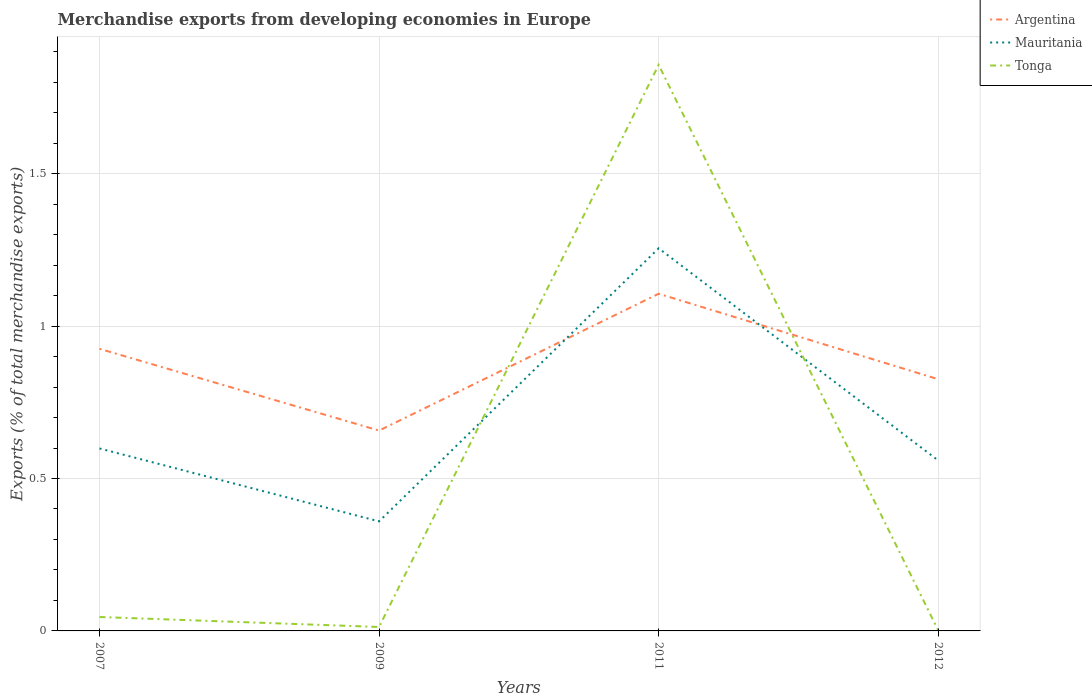How many different coloured lines are there?
Make the answer very short. 3. Across all years, what is the maximum percentage of total merchandise exports in Tonga?
Ensure brevity in your answer.  0. In which year was the percentage of total merchandise exports in Mauritania maximum?
Offer a very short reply. 2009. What is the total percentage of total merchandise exports in Argentina in the graph?
Provide a short and direct response. -0.45. What is the difference between the highest and the second highest percentage of total merchandise exports in Mauritania?
Make the answer very short. 0.9. How many lines are there?
Provide a succinct answer. 3. How many years are there in the graph?
Your response must be concise. 4. What is the difference between two consecutive major ticks on the Y-axis?
Your answer should be very brief. 0.5. Does the graph contain any zero values?
Your answer should be very brief. No. How many legend labels are there?
Keep it short and to the point. 3. How are the legend labels stacked?
Give a very brief answer. Vertical. What is the title of the graph?
Your answer should be very brief. Merchandise exports from developing economies in Europe. What is the label or title of the X-axis?
Provide a short and direct response. Years. What is the label or title of the Y-axis?
Give a very brief answer. Exports (% of total merchandise exports). What is the Exports (% of total merchandise exports) of Argentina in 2007?
Your answer should be very brief. 0.93. What is the Exports (% of total merchandise exports) of Mauritania in 2007?
Keep it short and to the point. 0.6. What is the Exports (% of total merchandise exports) of Tonga in 2007?
Your answer should be compact. 0.05. What is the Exports (% of total merchandise exports) in Argentina in 2009?
Make the answer very short. 0.66. What is the Exports (% of total merchandise exports) of Mauritania in 2009?
Keep it short and to the point. 0.36. What is the Exports (% of total merchandise exports) in Tonga in 2009?
Make the answer very short. 0.01. What is the Exports (% of total merchandise exports) of Argentina in 2011?
Offer a very short reply. 1.11. What is the Exports (% of total merchandise exports) of Mauritania in 2011?
Give a very brief answer. 1.26. What is the Exports (% of total merchandise exports) of Tonga in 2011?
Ensure brevity in your answer.  1.86. What is the Exports (% of total merchandise exports) of Argentina in 2012?
Your answer should be very brief. 0.83. What is the Exports (% of total merchandise exports) of Mauritania in 2012?
Ensure brevity in your answer.  0.56. What is the Exports (% of total merchandise exports) of Tonga in 2012?
Your response must be concise. 0. Across all years, what is the maximum Exports (% of total merchandise exports) in Argentina?
Offer a very short reply. 1.11. Across all years, what is the maximum Exports (% of total merchandise exports) of Mauritania?
Offer a terse response. 1.26. Across all years, what is the maximum Exports (% of total merchandise exports) of Tonga?
Give a very brief answer. 1.86. Across all years, what is the minimum Exports (% of total merchandise exports) in Argentina?
Give a very brief answer. 0.66. Across all years, what is the minimum Exports (% of total merchandise exports) of Mauritania?
Give a very brief answer. 0.36. Across all years, what is the minimum Exports (% of total merchandise exports) in Tonga?
Your response must be concise. 0. What is the total Exports (% of total merchandise exports) of Argentina in the graph?
Keep it short and to the point. 3.51. What is the total Exports (% of total merchandise exports) of Mauritania in the graph?
Your response must be concise. 2.77. What is the total Exports (% of total merchandise exports) in Tonga in the graph?
Give a very brief answer. 1.92. What is the difference between the Exports (% of total merchandise exports) in Argentina in 2007 and that in 2009?
Keep it short and to the point. 0.27. What is the difference between the Exports (% of total merchandise exports) of Mauritania in 2007 and that in 2009?
Ensure brevity in your answer.  0.24. What is the difference between the Exports (% of total merchandise exports) of Tonga in 2007 and that in 2009?
Provide a short and direct response. 0.03. What is the difference between the Exports (% of total merchandise exports) in Argentina in 2007 and that in 2011?
Your answer should be compact. -0.18. What is the difference between the Exports (% of total merchandise exports) of Mauritania in 2007 and that in 2011?
Your answer should be compact. -0.66. What is the difference between the Exports (% of total merchandise exports) in Tonga in 2007 and that in 2011?
Keep it short and to the point. -1.81. What is the difference between the Exports (% of total merchandise exports) in Argentina in 2007 and that in 2012?
Your answer should be compact. 0.1. What is the difference between the Exports (% of total merchandise exports) in Mauritania in 2007 and that in 2012?
Your answer should be very brief. 0.04. What is the difference between the Exports (% of total merchandise exports) of Tonga in 2007 and that in 2012?
Your response must be concise. 0.04. What is the difference between the Exports (% of total merchandise exports) in Argentina in 2009 and that in 2011?
Provide a short and direct response. -0.45. What is the difference between the Exports (% of total merchandise exports) in Mauritania in 2009 and that in 2011?
Offer a terse response. -0.9. What is the difference between the Exports (% of total merchandise exports) in Tonga in 2009 and that in 2011?
Your answer should be very brief. -1.84. What is the difference between the Exports (% of total merchandise exports) of Argentina in 2009 and that in 2012?
Make the answer very short. -0.17. What is the difference between the Exports (% of total merchandise exports) in Mauritania in 2009 and that in 2012?
Provide a short and direct response. -0.2. What is the difference between the Exports (% of total merchandise exports) in Tonga in 2009 and that in 2012?
Provide a short and direct response. 0.01. What is the difference between the Exports (% of total merchandise exports) in Argentina in 2011 and that in 2012?
Your answer should be compact. 0.28. What is the difference between the Exports (% of total merchandise exports) of Mauritania in 2011 and that in 2012?
Make the answer very short. 0.7. What is the difference between the Exports (% of total merchandise exports) in Tonga in 2011 and that in 2012?
Make the answer very short. 1.86. What is the difference between the Exports (% of total merchandise exports) of Argentina in 2007 and the Exports (% of total merchandise exports) of Mauritania in 2009?
Keep it short and to the point. 0.57. What is the difference between the Exports (% of total merchandise exports) of Argentina in 2007 and the Exports (% of total merchandise exports) of Tonga in 2009?
Keep it short and to the point. 0.91. What is the difference between the Exports (% of total merchandise exports) of Mauritania in 2007 and the Exports (% of total merchandise exports) of Tonga in 2009?
Ensure brevity in your answer.  0.59. What is the difference between the Exports (% of total merchandise exports) in Argentina in 2007 and the Exports (% of total merchandise exports) in Mauritania in 2011?
Offer a terse response. -0.33. What is the difference between the Exports (% of total merchandise exports) of Argentina in 2007 and the Exports (% of total merchandise exports) of Tonga in 2011?
Give a very brief answer. -0.93. What is the difference between the Exports (% of total merchandise exports) in Mauritania in 2007 and the Exports (% of total merchandise exports) in Tonga in 2011?
Offer a very short reply. -1.26. What is the difference between the Exports (% of total merchandise exports) of Argentina in 2007 and the Exports (% of total merchandise exports) of Mauritania in 2012?
Offer a very short reply. 0.37. What is the difference between the Exports (% of total merchandise exports) in Argentina in 2007 and the Exports (% of total merchandise exports) in Tonga in 2012?
Provide a succinct answer. 0.92. What is the difference between the Exports (% of total merchandise exports) of Mauritania in 2007 and the Exports (% of total merchandise exports) of Tonga in 2012?
Ensure brevity in your answer.  0.6. What is the difference between the Exports (% of total merchandise exports) in Argentina in 2009 and the Exports (% of total merchandise exports) in Mauritania in 2011?
Provide a succinct answer. -0.6. What is the difference between the Exports (% of total merchandise exports) of Argentina in 2009 and the Exports (% of total merchandise exports) of Tonga in 2011?
Your answer should be compact. -1.2. What is the difference between the Exports (% of total merchandise exports) of Mauritania in 2009 and the Exports (% of total merchandise exports) of Tonga in 2011?
Give a very brief answer. -1.5. What is the difference between the Exports (% of total merchandise exports) in Argentina in 2009 and the Exports (% of total merchandise exports) in Mauritania in 2012?
Provide a short and direct response. 0.1. What is the difference between the Exports (% of total merchandise exports) of Argentina in 2009 and the Exports (% of total merchandise exports) of Tonga in 2012?
Provide a succinct answer. 0.66. What is the difference between the Exports (% of total merchandise exports) of Mauritania in 2009 and the Exports (% of total merchandise exports) of Tonga in 2012?
Your answer should be compact. 0.36. What is the difference between the Exports (% of total merchandise exports) in Argentina in 2011 and the Exports (% of total merchandise exports) in Mauritania in 2012?
Offer a terse response. 0.55. What is the difference between the Exports (% of total merchandise exports) in Argentina in 2011 and the Exports (% of total merchandise exports) in Tonga in 2012?
Offer a terse response. 1.1. What is the difference between the Exports (% of total merchandise exports) of Mauritania in 2011 and the Exports (% of total merchandise exports) of Tonga in 2012?
Your answer should be compact. 1.25. What is the average Exports (% of total merchandise exports) of Argentina per year?
Offer a terse response. 0.88. What is the average Exports (% of total merchandise exports) in Mauritania per year?
Provide a succinct answer. 0.69. What is the average Exports (% of total merchandise exports) in Tonga per year?
Offer a very short reply. 0.48. In the year 2007, what is the difference between the Exports (% of total merchandise exports) of Argentina and Exports (% of total merchandise exports) of Mauritania?
Keep it short and to the point. 0.33. In the year 2007, what is the difference between the Exports (% of total merchandise exports) of Argentina and Exports (% of total merchandise exports) of Tonga?
Provide a short and direct response. 0.88. In the year 2007, what is the difference between the Exports (% of total merchandise exports) in Mauritania and Exports (% of total merchandise exports) in Tonga?
Ensure brevity in your answer.  0.55. In the year 2009, what is the difference between the Exports (% of total merchandise exports) in Argentina and Exports (% of total merchandise exports) in Mauritania?
Offer a very short reply. 0.3. In the year 2009, what is the difference between the Exports (% of total merchandise exports) in Argentina and Exports (% of total merchandise exports) in Tonga?
Provide a succinct answer. 0.64. In the year 2009, what is the difference between the Exports (% of total merchandise exports) of Mauritania and Exports (% of total merchandise exports) of Tonga?
Make the answer very short. 0.35. In the year 2011, what is the difference between the Exports (% of total merchandise exports) of Argentina and Exports (% of total merchandise exports) of Mauritania?
Give a very brief answer. -0.15. In the year 2011, what is the difference between the Exports (% of total merchandise exports) in Argentina and Exports (% of total merchandise exports) in Tonga?
Provide a short and direct response. -0.75. In the year 2011, what is the difference between the Exports (% of total merchandise exports) in Mauritania and Exports (% of total merchandise exports) in Tonga?
Your answer should be compact. -0.6. In the year 2012, what is the difference between the Exports (% of total merchandise exports) of Argentina and Exports (% of total merchandise exports) of Mauritania?
Your answer should be compact. 0.27. In the year 2012, what is the difference between the Exports (% of total merchandise exports) in Argentina and Exports (% of total merchandise exports) in Tonga?
Ensure brevity in your answer.  0.82. In the year 2012, what is the difference between the Exports (% of total merchandise exports) in Mauritania and Exports (% of total merchandise exports) in Tonga?
Your answer should be very brief. 0.56. What is the ratio of the Exports (% of total merchandise exports) of Argentina in 2007 to that in 2009?
Your answer should be very brief. 1.41. What is the ratio of the Exports (% of total merchandise exports) of Mauritania in 2007 to that in 2009?
Keep it short and to the point. 1.67. What is the ratio of the Exports (% of total merchandise exports) of Tonga in 2007 to that in 2009?
Ensure brevity in your answer.  3.53. What is the ratio of the Exports (% of total merchandise exports) in Argentina in 2007 to that in 2011?
Give a very brief answer. 0.84. What is the ratio of the Exports (% of total merchandise exports) of Mauritania in 2007 to that in 2011?
Provide a short and direct response. 0.48. What is the ratio of the Exports (% of total merchandise exports) in Tonga in 2007 to that in 2011?
Your response must be concise. 0.02. What is the ratio of the Exports (% of total merchandise exports) in Argentina in 2007 to that in 2012?
Your answer should be very brief. 1.12. What is the ratio of the Exports (% of total merchandise exports) of Mauritania in 2007 to that in 2012?
Offer a terse response. 1.07. What is the ratio of the Exports (% of total merchandise exports) in Tonga in 2007 to that in 2012?
Offer a terse response. 24.23. What is the ratio of the Exports (% of total merchandise exports) in Argentina in 2009 to that in 2011?
Give a very brief answer. 0.59. What is the ratio of the Exports (% of total merchandise exports) in Mauritania in 2009 to that in 2011?
Offer a terse response. 0.29. What is the ratio of the Exports (% of total merchandise exports) in Tonga in 2009 to that in 2011?
Provide a short and direct response. 0.01. What is the ratio of the Exports (% of total merchandise exports) in Argentina in 2009 to that in 2012?
Your answer should be compact. 0.8. What is the ratio of the Exports (% of total merchandise exports) of Mauritania in 2009 to that in 2012?
Your response must be concise. 0.64. What is the ratio of the Exports (% of total merchandise exports) of Tonga in 2009 to that in 2012?
Offer a terse response. 6.86. What is the ratio of the Exports (% of total merchandise exports) of Argentina in 2011 to that in 2012?
Provide a succinct answer. 1.34. What is the ratio of the Exports (% of total merchandise exports) in Mauritania in 2011 to that in 2012?
Provide a short and direct response. 2.24. What is the ratio of the Exports (% of total merchandise exports) of Tonga in 2011 to that in 2012?
Give a very brief answer. 985.14. What is the difference between the highest and the second highest Exports (% of total merchandise exports) of Argentina?
Offer a very short reply. 0.18. What is the difference between the highest and the second highest Exports (% of total merchandise exports) in Mauritania?
Your answer should be very brief. 0.66. What is the difference between the highest and the second highest Exports (% of total merchandise exports) in Tonga?
Your response must be concise. 1.81. What is the difference between the highest and the lowest Exports (% of total merchandise exports) in Argentina?
Your answer should be compact. 0.45. What is the difference between the highest and the lowest Exports (% of total merchandise exports) of Mauritania?
Provide a succinct answer. 0.9. What is the difference between the highest and the lowest Exports (% of total merchandise exports) of Tonga?
Give a very brief answer. 1.86. 